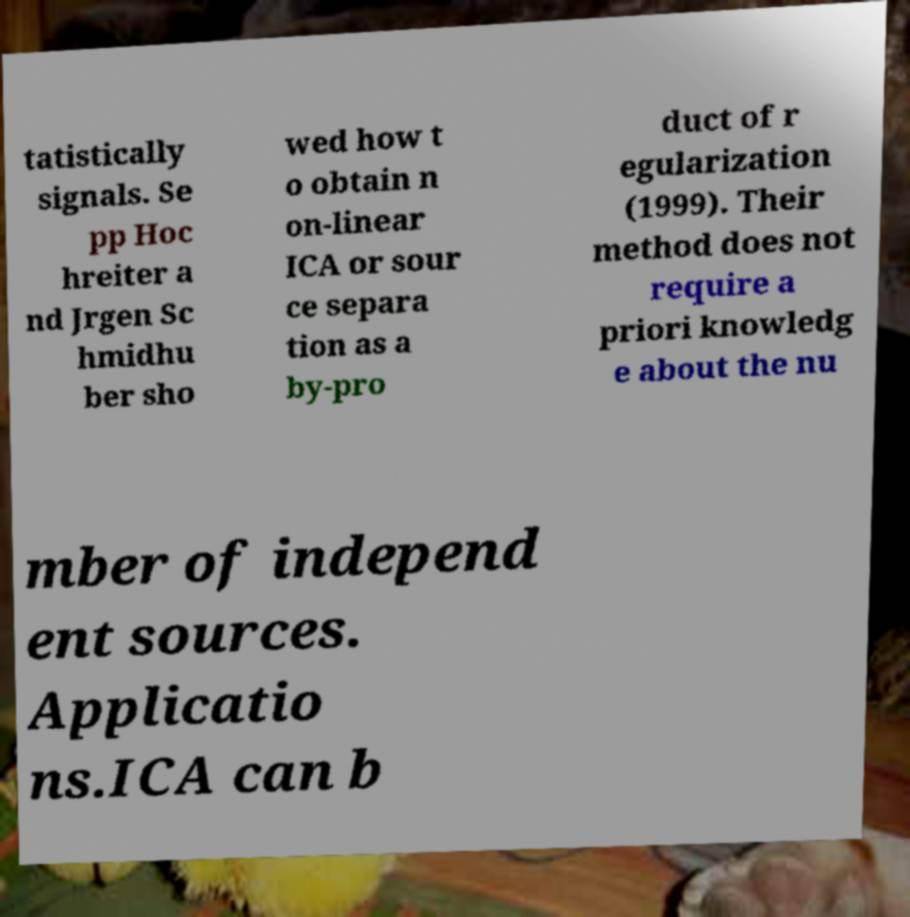Could you extract and type out the text from this image? tatistically signals. Se pp Hoc hreiter a nd Jrgen Sc hmidhu ber sho wed how t o obtain n on-linear ICA or sour ce separa tion as a by-pro duct of r egularization (1999). Their method does not require a priori knowledg e about the nu mber of independ ent sources. Applicatio ns.ICA can b 